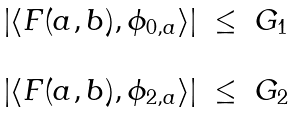Convert formula to latex. <formula><loc_0><loc_0><loc_500><loc_500>\begin{array} { l l l } | \langle F ( a , b ) , \phi _ { 0 , a } \rangle | & \leq & G _ { 1 } \\ & & \\ | \langle F ( a , b ) , \phi _ { 2 , a } \rangle | & \leq & G _ { 2 } \end{array}</formula> 